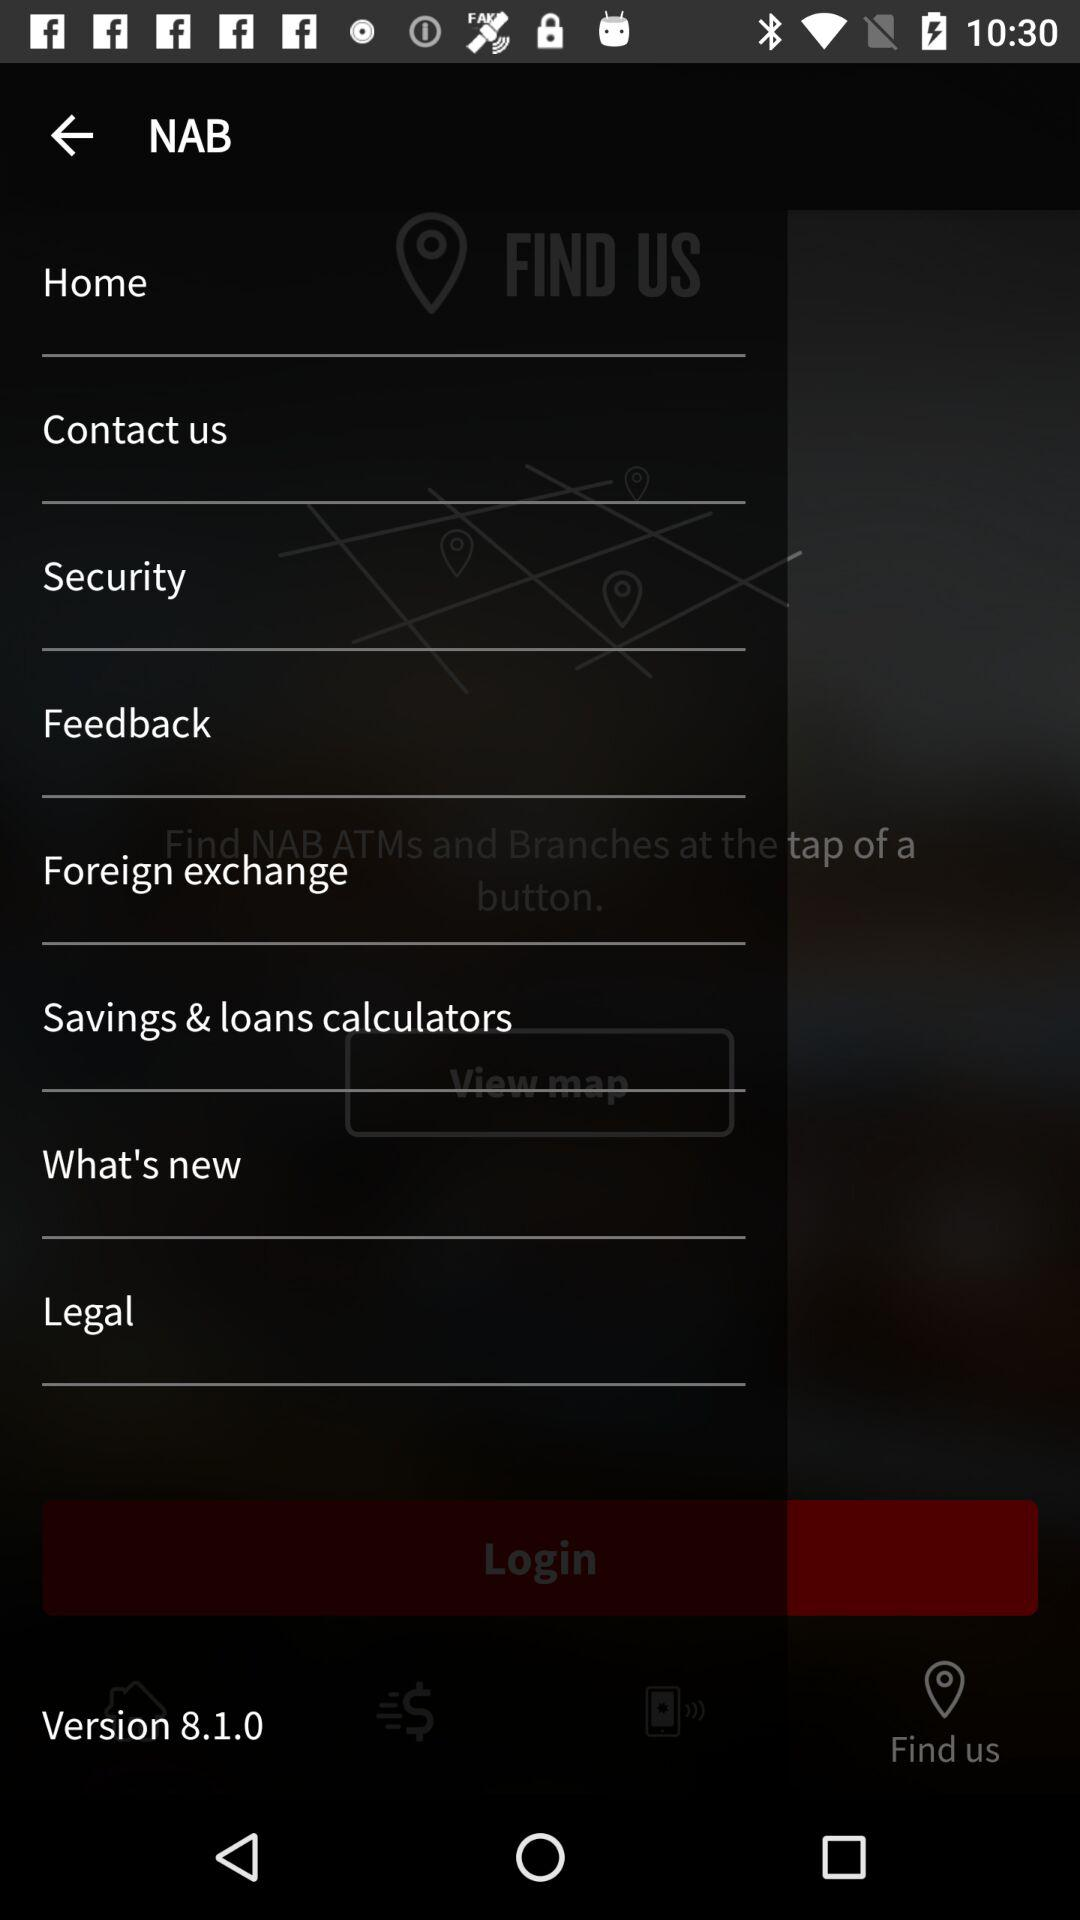What is the version? The version is 8.1.0. 